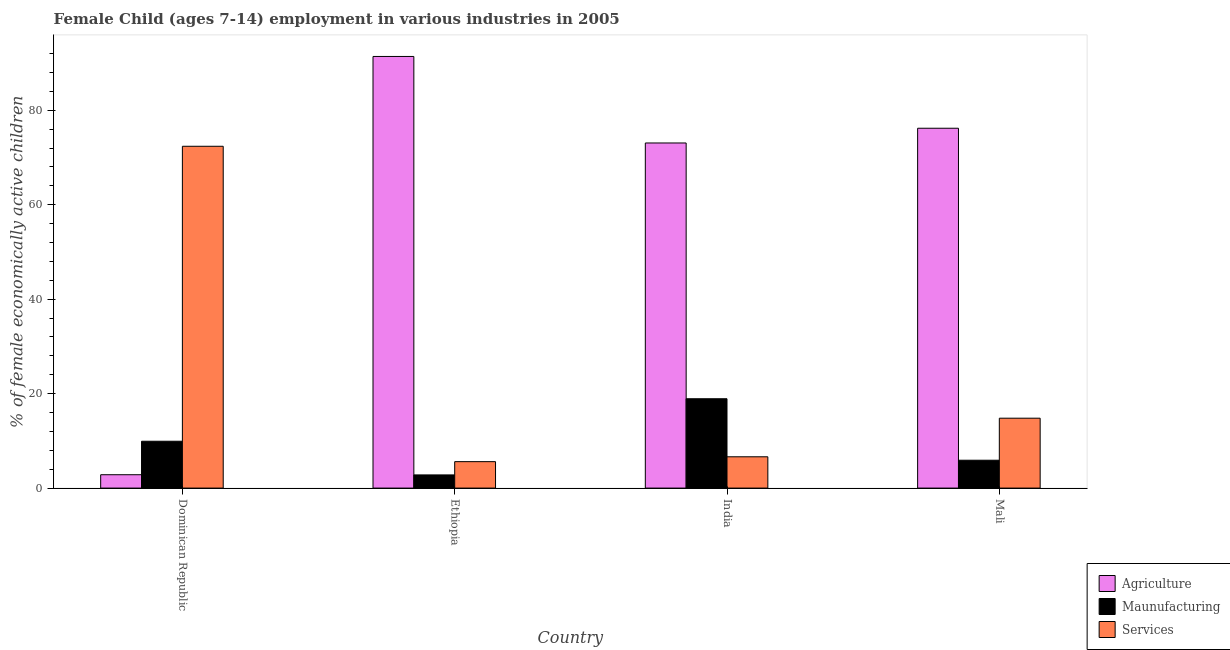How many groups of bars are there?
Provide a short and direct response. 4. Are the number of bars per tick equal to the number of legend labels?
Provide a succinct answer. Yes. How many bars are there on the 3rd tick from the right?
Offer a very short reply. 3. In how many cases, is the number of bars for a given country not equal to the number of legend labels?
Keep it short and to the point. 0. What is the percentage of economically active children in services in India?
Give a very brief answer. 6.63. Across all countries, what is the maximum percentage of economically active children in manufacturing?
Your response must be concise. 18.92. Across all countries, what is the minimum percentage of economically active children in manufacturing?
Provide a short and direct response. 2.79. In which country was the percentage of economically active children in services maximum?
Keep it short and to the point. Dominican Republic. In which country was the percentage of economically active children in manufacturing minimum?
Keep it short and to the point. Ethiopia. What is the total percentage of economically active children in services in the graph?
Offer a terse response. 99.41. What is the difference between the percentage of economically active children in manufacturing in Dominican Republic and that in India?
Keep it short and to the point. -9. What is the difference between the percentage of economically active children in agriculture in Mali and the percentage of economically active children in services in India?
Offer a terse response. 69.57. What is the average percentage of economically active children in services per country?
Give a very brief answer. 24.85. What is the difference between the percentage of economically active children in manufacturing and percentage of economically active children in agriculture in Mali?
Ensure brevity in your answer.  -70.3. In how many countries, is the percentage of economically active children in services greater than 56 %?
Your answer should be very brief. 1. What is the ratio of the percentage of economically active children in services in Dominican Republic to that in India?
Your answer should be compact. 10.92. Is the percentage of economically active children in services in Ethiopia less than that in India?
Your response must be concise. Yes. Is the difference between the percentage of economically active children in agriculture in Dominican Republic and India greater than the difference between the percentage of economically active children in services in Dominican Republic and India?
Offer a terse response. No. What is the difference between the highest and the second highest percentage of economically active children in manufacturing?
Provide a short and direct response. 9. What is the difference between the highest and the lowest percentage of economically active children in services?
Ensure brevity in your answer.  66.78. Is the sum of the percentage of economically active children in services in India and Mali greater than the maximum percentage of economically active children in agriculture across all countries?
Give a very brief answer. No. What does the 2nd bar from the left in India represents?
Give a very brief answer. Maunufacturing. What does the 3rd bar from the right in Dominican Republic represents?
Your answer should be compact. Agriculture. Is it the case that in every country, the sum of the percentage of economically active children in agriculture and percentage of economically active children in manufacturing is greater than the percentage of economically active children in services?
Provide a short and direct response. No. How many bars are there?
Offer a very short reply. 12. What is the difference between two consecutive major ticks on the Y-axis?
Your answer should be very brief. 20. Are the values on the major ticks of Y-axis written in scientific E-notation?
Provide a succinct answer. No. Does the graph contain grids?
Keep it short and to the point. No. How many legend labels are there?
Keep it short and to the point. 3. What is the title of the graph?
Your answer should be very brief. Female Child (ages 7-14) employment in various industries in 2005. Does "Other sectors" appear as one of the legend labels in the graph?
Your answer should be compact. No. What is the label or title of the Y-axis?
Keep it short and to the point. % of female economically active children. What is the % of female economically active children of Agriculture in Dominican Republic?
Ensure brevity in your answer.  2.83. What is the % of female economically active children of Maunufacturing in Dominican Republic?
Ensure brevity in your answer.  9.92. What is the % of female economically active children of Services in Dominican Republic?
Keep it short and to the point. 72.38. What is the % of female economically active children in Agriculture in Ethiopia?
Provide a short and direct response. 91.4. What is the % of female economically active children in Maunufacturing in Ethiopia?
Give a very brief answer. 2.79. What is the % of female economically active children in Agriculture in India?
Your response must be concise. 73.08. What is the % of female economically active children of Maunufacturing in India?
Make the answer very short. 18.92. What is the % of female economically active children in Services in India?
Provide a short and direct response. 6.63. What is the % of female economically active children of Agriculture in Mali?
Provide a succinct answer. 76.2. What is the % of female economically active children in Maunufacturing in Mali?
Your response must be concise. 5.9. Across all countries, what is the maximum % of female economically active children of Agriculture?
Give a very brief answer. 91.4. Across all countries, what is the maximum % of female economically active children in Maunufacturing?
Offer a terse response. 18.92. Across all countries, what is the maximum % of female economically active children of Services?
Offer a very short reply. 72.38. Across all countries, what is the minimum % of female economically active children of Agriculture?
Ensure brevity in your answer.  2.83. Across all countries, what is the minimum % of female economically active children in Maunufacturing?
Give a very brief answer. 2.79. What is the total % of female economically active children in Agriculture in the graph?
Your answer should be very brief. 243.51. What is the total % of female economically active children in Maunufacturing in the graph?
Ensure brevity in your answer.  37.53. What is the total % of female economically active children in Services in the graph?
Your response must be concise. 99.41. What is the difference between the % of female economically active children of Agriculture in Dominican Republic and that in Ethiopia?
Your response must be concise. -88.57. What is the difference between the % of female economically active children in Maunufacturing in Dominican Republic and that in Ethiopia?
Give a very brief answer. 7.13. What is the difference between the % of female economically active children of Services in Dominican Republic and that in Ethiopia?
Provide a succinct answer. 66.78. What is the difference between the % of female economically active children in Agriculture in Dominican Republic and that in India?
Make the answer very short. -70.25. What is the difference between the % of female economically active children in Services in Dominican Republic and that in India?
Ensure brevity in your answer.  65.75. What is the difference between the % of female economically active children in Agriculture in Dominican Republic and that in Mali?
Your response must be concise. -73.37. What is the difference between the % of female economically active children of Maunufacturing in Dominican Republic and that in Mali?
Keep it short and to the point. 4.02. What is the difference between the % of female economically active children in Services in Dominican Republic and that in Mali?
Offer a very short reply. 57.58. What is the difference between the % of female economically active children in Agriculture in Ethiopia and that in India?
Your answer should be very brief. 18.32. What is the difference between the % of female economically active children in Maunufacturing in Ethiopia and that in India?
Offer a very short reply. -16.13. What is the difference between the % of female economically active children of Services in Ethiopia and that in India?
Your response must be concise. -1.03. What is the difference between the % of female economically active children in Maunufacturing in Ethiopia and that in Mali?
Keep it short and to the point. -3.11. What is the difference between the % of female economically active children in Services in Ethiopia and that in Mali?
Your response must be concise. -9.2. What is the difference between the % of female economically active children in Agriculture in India and that in Mali?
Provide a succinct answer. -3.12. What is the difference between the % of female economically active children of Maunufacturing in India and that in Mali?
Give a very brief answer. 13.02. What is the difference between the % of female economically active children in Services in India and that in Mali?
Keep it short and to the point. -8.17. What is the difference between the % of female economically active children of Agriculture in Dominican Republic and the % of female economically active children of Services in Ethiopia?
Ensure brevity in your answer.  -2.77. What is the difference between the % of female economically active children of Maunufacturing in Dominican Republic and the % of female economically active children of Services in Ethiopia?
Your answer should be very brief. 4.32. What is the difference between the % of female economically active children in Agriculture in Dominican Republic and the % of female economically active children in Maunufacturing in India?
Offer a terse response. -16.09. What is the difference between the % of female economically active children in Maunufacturing in Dominican Republic and the % of female economically active children in Services in India?
Your answer should be very brief. 3.29. What is the difference between the % of female economically active children of Agriculture in Dominican Republic and the % of female economically active children of Maunufacturing in Mali?
Your response must be concise. -3.07. What is the difference between the % of female economically active children of Agriculture in Dominican Republic and the % of female economically active children of Services in Mali?
Give a very brief answer. -11.97. What is the difference between the % of female economically active children of Maunufacturing in Dominican Republic and the % of female economically active children of Services in Mali?
Make the answer very short. -4.88. What is the difference between the % of female economically active children in Agriculture in Ethiopia and the % of female economically active children in Maunufacturing in India?
Ensure brevity in your answer.  72.48. What is the difference between the % of female economically active children in Agriculture in Ethiopia and the % of female economically active children in Services in India?
Make the answer very short. 84.77. What is the difference between the % of female economically active children in Maunufacturing in Ethiopia and the % of female economically active children in Services in India?
Provide a short and direct response. -3.84. What is the difference between the % of female economically active children in Agriculture in Ethiopia and the % of female economically active children in Maunufacturing in Mali?
Your response must be concise. 85.5. What is the difference between the % of female economically active children in Agriculture in Ethiopia and the % of female economically active children in Services in Mali?
Keep it short and to the point. 76.6. What is the difference between the % of female economically active children in Maunufacturing in Ethiopia and the % of female economically active children in Services in Mali?
Keep it short and to the point. -12.01. What is the difference between the % of female economically active children in Agriculture in India and the % of female economically active children in Maunufacturing in Mali?
Keep it short and to the point. 67.18. What is the difference between the % of female economically active children in Agriculture in India and the % of female economically active children in Services in Mali?
Keep it short and to the point. 58.28. What is the difference between the % of female economically active children in Maunufacturing in India and the % of female economically active children in Services in Mali?
Make the answer very short. 4.12. What is the average % of female economically active children in Agriculture per country?
Give a very brief answer. 60.88. What is the average % of female economically active children of Maunufacturing per country?
Your response must be concise. 9.38. What is the average % of female economically active children of Services per country?
Ensure brevity in your answer.  24.85. What is the difference between the % of female economically active children of Agriculture and % of female economically active children of Maunufacturing in Dominican Republic?
Provide a short and direct response. -7.09. What is the difference between the % of female economically active children in Agriculture and % of female economically active children in Services in Dominican Republic?
Offer a terse response. -69.55. What is the difference between the % of female economically active children in Maunufacturing and % of female economically active children in Services in Dominican Republic?
Give a very brief answer. -62.46. What is the difference between the % of female economically active children of Agriculture and % of female economically active children of Maunufacturing in Ethiopia?
Keep it short and to the point. 88.61. What is the difference between the % of female economically active children in Agriculture and % of female economically active children in Services in Ethiopia?
Make the answer very short. 85.8. What is the difference between the % of female economically active children of Maunufacturing and % of female economically active children of Services in Ethiopia?
Keep it short and to the point. -2.81. What is the difference between the % of female economically active children of Agriculture and % of female economically active children of Maunufacturing in India?
Provide a succinct answer. 54.16. What is the difference between the % of female economically active children in Agriculture and % of female economically active children in Services in India?
Offer a very short reply. 66.45. What is the difference between the % of female economically active children of Maunufacturing and % of female economically active children of Services in India?
Provide a short and direct response. 12.29. What is the difference between the % of female economically active children of Agriculture and % of female economically active children of Maunufacturing in Mali?
Your answer should be very brief. 70.3. What is the difference between the % of female economically active children of Agriculture and % of female economically active children of Services in Mali?
Offer a terse response. 61.4. What is the ratio of the % of female economically active children in Agriculture in Dominican Republic to that in Ethiopia?
Ensure brevity in your answer.  0.03. What is the ratio of the % of female economically active children of Maunufacturing in Dominican Republic to that in Ethiopia?
Provide a succinct answer. 3.56. What is the ratio of the % of female economically active children of Services in Dominican Republic to that in Ethiopia?
Provide a succinct answer. 12.93. What is the ratio of the % of female economically active children of Agriculture in Dominican Republic to that in India?
Keep it short and to the point. 0.04. What is the ratio of the % of female economically active children of Maunufacturing in Dominican Republic to that in India?
Keep it short and to the point. 0.52. What is the ratio of the % of female economically active children of Services in Dominican Republic to that in India?
Give a very brief answer. 10.92. What is the ratio of the % of female economically active children of Agriculture in Dominican Republic to that in Mali?
Offer a very short reply. 0.04. What is the ratio of the % of female economically active children of Maunufacturing in Dominican Republic to that in Mali?
Your answer should be compact. 1.68. What is the ratio of the % of female economically active children in Services in Dominican Republic to that in Mali?
Give a very brief answer. 4.89. What is the ratio of the % of female economically active children of Agriculture in Ethiopia to that in India?
Your answer should be very brief. 1.25. What is the ratio of the % of female economically active children of Maunufacturing in Ethiopia to that in India?
Give a very brief answer. 0.15. What is the ratio of the % of female economically active children in Services in Ethiopia to that in India?
Your answer should be compact. 0.84. What is the ratio of the % of female economically active children in Agriculture in Ethiopia to that in Mali?
Your answer should be very brief. 1.2. What is the ratio of the % of female economically active children of Maunufacturing in Ethiopia to that in Mali?
Make the answer very short. 0.47. What is the ratio of the % of female economically active children of Services in Ethiopia to that in Mali?
Your response must be concise. 0.38. What is the ratio of the % of female economically active children of Agriculture in India to that in Mali?
Your answer should be very brief. 0.96. What is the ratio of the % of female economically active children of Maunufacturing in India to that in Mali?
Offer a very short reply. 3.21. What is the ratio of the % of female economically active children in Services in India to that in Mali?
Your answer should be very brief. 0.45. What is the difference between the highest and the second highest % of female economically active children of Agriculture?
Give a very brief answer. 15.2. What is the difference between the highest and the second highest % of female economically active children in Services?
Provide a short and direct response. 57.58. What is the difference between the highest and the lowest % of female economically active children of Agriculture?
Your answer should be very brief. 88.57. What is the difference between the highest and the lowest % of female economically active children of Maunufacturing?
Your answer should be very brief. 16.13. What is the difference between the highest and the lowest % of female economically active children in Services?
Offer a terse response. 66.78. 